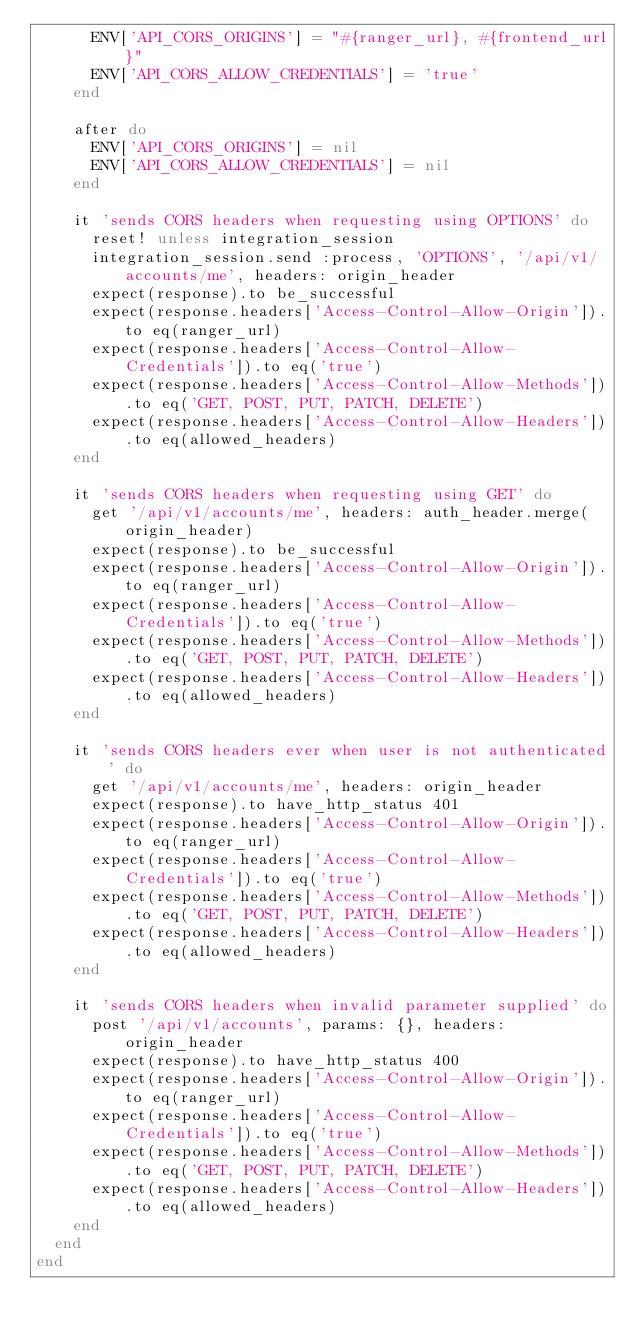<code> <loc_0><loc_0><loc_500><loc_500><_Ruby_>      ENV['API_CORS_ORIGINS'] = "#{ranger_url}, #{frontend_url}"
      ENV['API_CORS_ALLOW_CREDENTIALS'] = 'true'
    end

    after do
      ENV['API_CORS_ORIGINS'] = nil
      ENV['API_CORS_ALLOW_CREDENTIALS'] = nil
    end

    it 'sends CORS headers when requesting using OPTIONS' do
      reset! unless integration_session
      integration_session.send :process, 'OPTIONS', '/api/v1/accounts/me', headers: origin_header
      expect(response).to be_successful
      expect(response.headers['Access-Control-Allow-Origin']).to eq(ranger_url)
      expect(response.headers['Access-Control-Allow-Credentials']).to eq('true')
      expect(response.headers['Access-Control-Allow-Methods']).to eq('GET, POST, PUT, PATCH, DELETE')
      expect(response.headers['Access-Control-Allow-Headers']).to eq(allowed_headers)
    end

    it 'sends CORS headers when requesting using GET' do
      get '/api/v1/accounts/me', headers: auth_header.merge(origin_header)
      expect(response).to be_successful
      expect(response.headers['Access-Control-Allow-Origin']).to eq(ranger_url)
      expect(response.headers['Access-Control-Allow-Credentials']).to eq('true')
      expect(response.headers['Access-Control-Allow-Methods']).to eq('GET, POST, PUT, PATCH, DELETE')
      expect(response.headers['Access-Control-Allow-Headers']).to eq(allowed_headers)
    end

    it 'sends CORS headers ever when user is not authenticated' do
      get '/api/v1/accounts/me', headers: origin_header
      expect(response).to have_http_status 401
      expect(response.headers['Access-Control-Allow-Origin']).to eq(ranger_url)
      expect(response.headers['Access-Control-Allow-Credentials']).to eq('true')
      expect(response.headers['Access-Control-Allow-Methods']).to eq('GET, POST, PUT, PATCH, DELETE')
      expect(response.headers['Access-Control-Allow-Headers']).to eq(allowed_headers)
    end

    it 'sends CORS headers when invalid parameter supplied' do
      post '/api/v1/accounts', params: {}, headers: origin_header
      expect(response).to have_http_status 400
      expect(response.headers['Access-Control-Allow-Origin']).to eq(ranger_url)
      expect(response.headers['Access-Control-Allow-Credentials']).to eq('true')
      expect(response.headers['Access-Control-Allow-Methods']).to eq('GET, POST, PUT, PATCH, DELETE')
      expect(response.headers['Access-Control-Allow-Headers']).to eq(allowed_headers)
    end
  end
end
</code> 